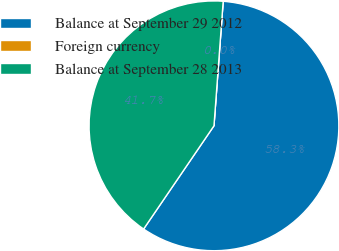Convert chart. <chart><loc_0><loc_0><loc_500><loc_500><pie_chart><fcel>Balance at September 29 2012<fcel>Foreign currency<fcel>Balance at September 28 2013<nl><fcel>58.35%<fcel>0.0%<fcel>41.65%<nl></chart> 